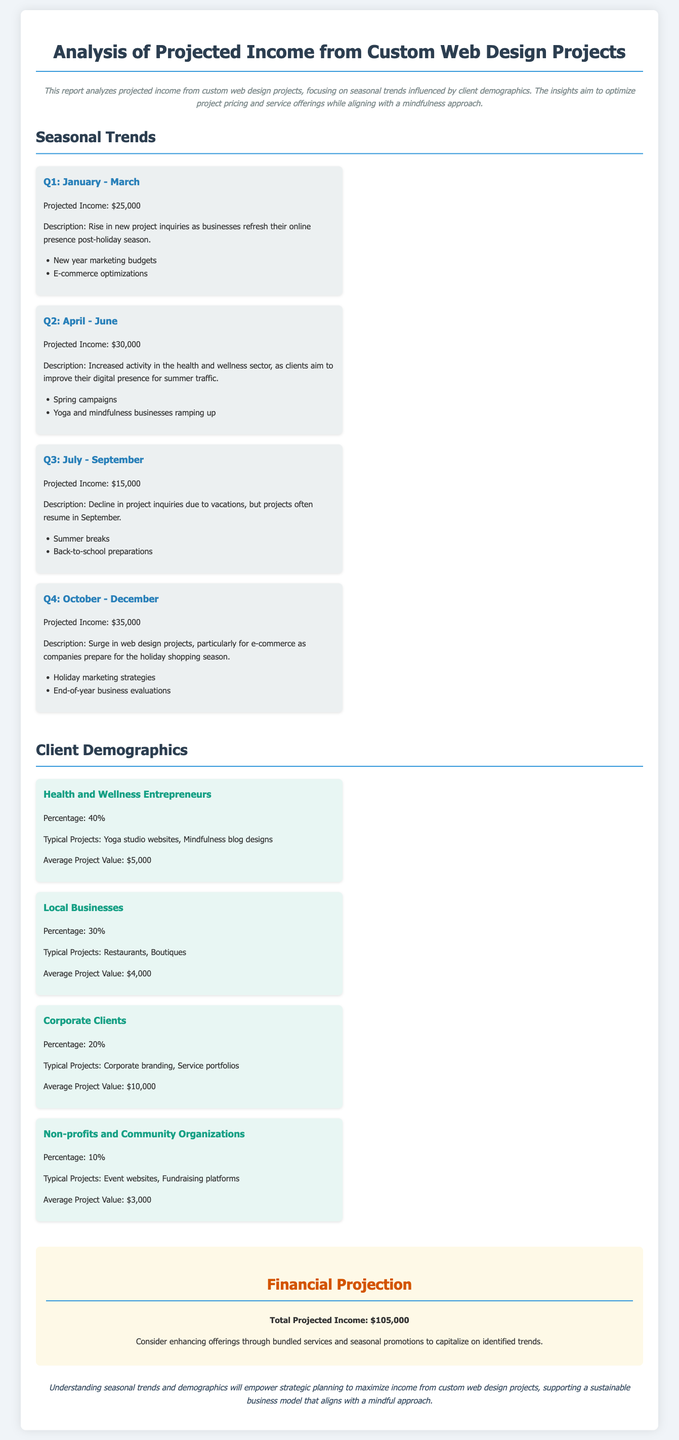what is the total projected income? The total projected income is presented in the financial projection section of the document.
Answer: $105,000 what is the projected income for Q2? The projected income for Q2 is specifically mentioned under the seasonal trends section.
Answer: $30,000 which client demographic has the highest percentage? The percentages for each client demographic are listed, indicating which has the highest proportion.
Answer: Health and Wellness Entrepreneurs what types of projects do local businesses typically request? The document outlines the typical projects that local businesses engage in.
Answer: Restaurants, Boutiques what is the projected income for Q3? The projected income for Q3 is detailed under the seasonal trends.
Answer: $15,000 how many client demographics are listed in the document? The document enumerates different client demographics in its demographics section.
Answer: Four what season is associated with a decline in project inquiries? The seasonal trends discuss variations in project inquiries based on the time of year.
Answer: Summer what is the average project value for non-profits and community organizations? The document provides average project values for each client demographic.
Answer: $3,000 which quarter sees a surge in web design projects? The seasonal trends indicate specific quarters that see increased project activity.
Answer: Q4: October - December 